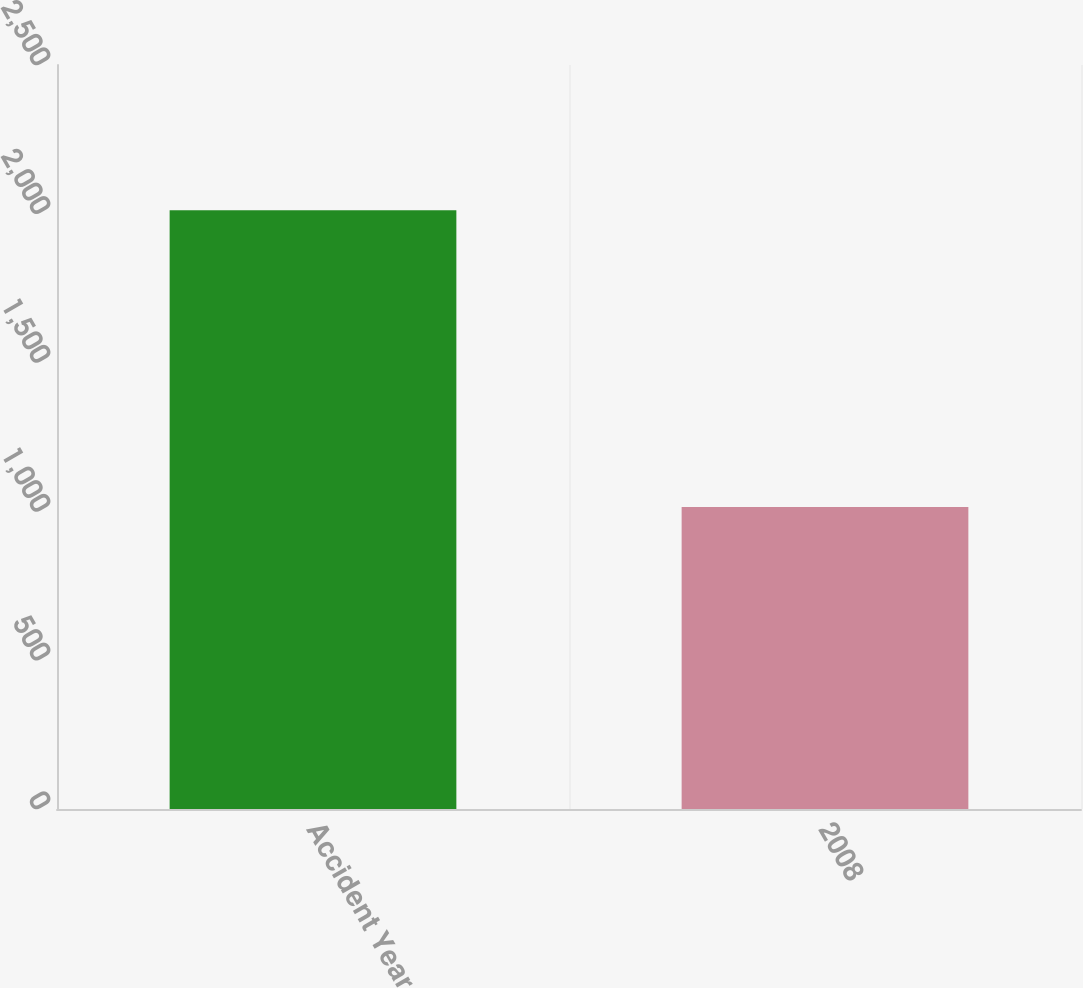<chart> <loc_0><loc_0><loc_500><loc_500><bar_chart><fcel>Accident Year<fcel>2008<nl><fcel>2012<fcel>1015<nl></chart> 